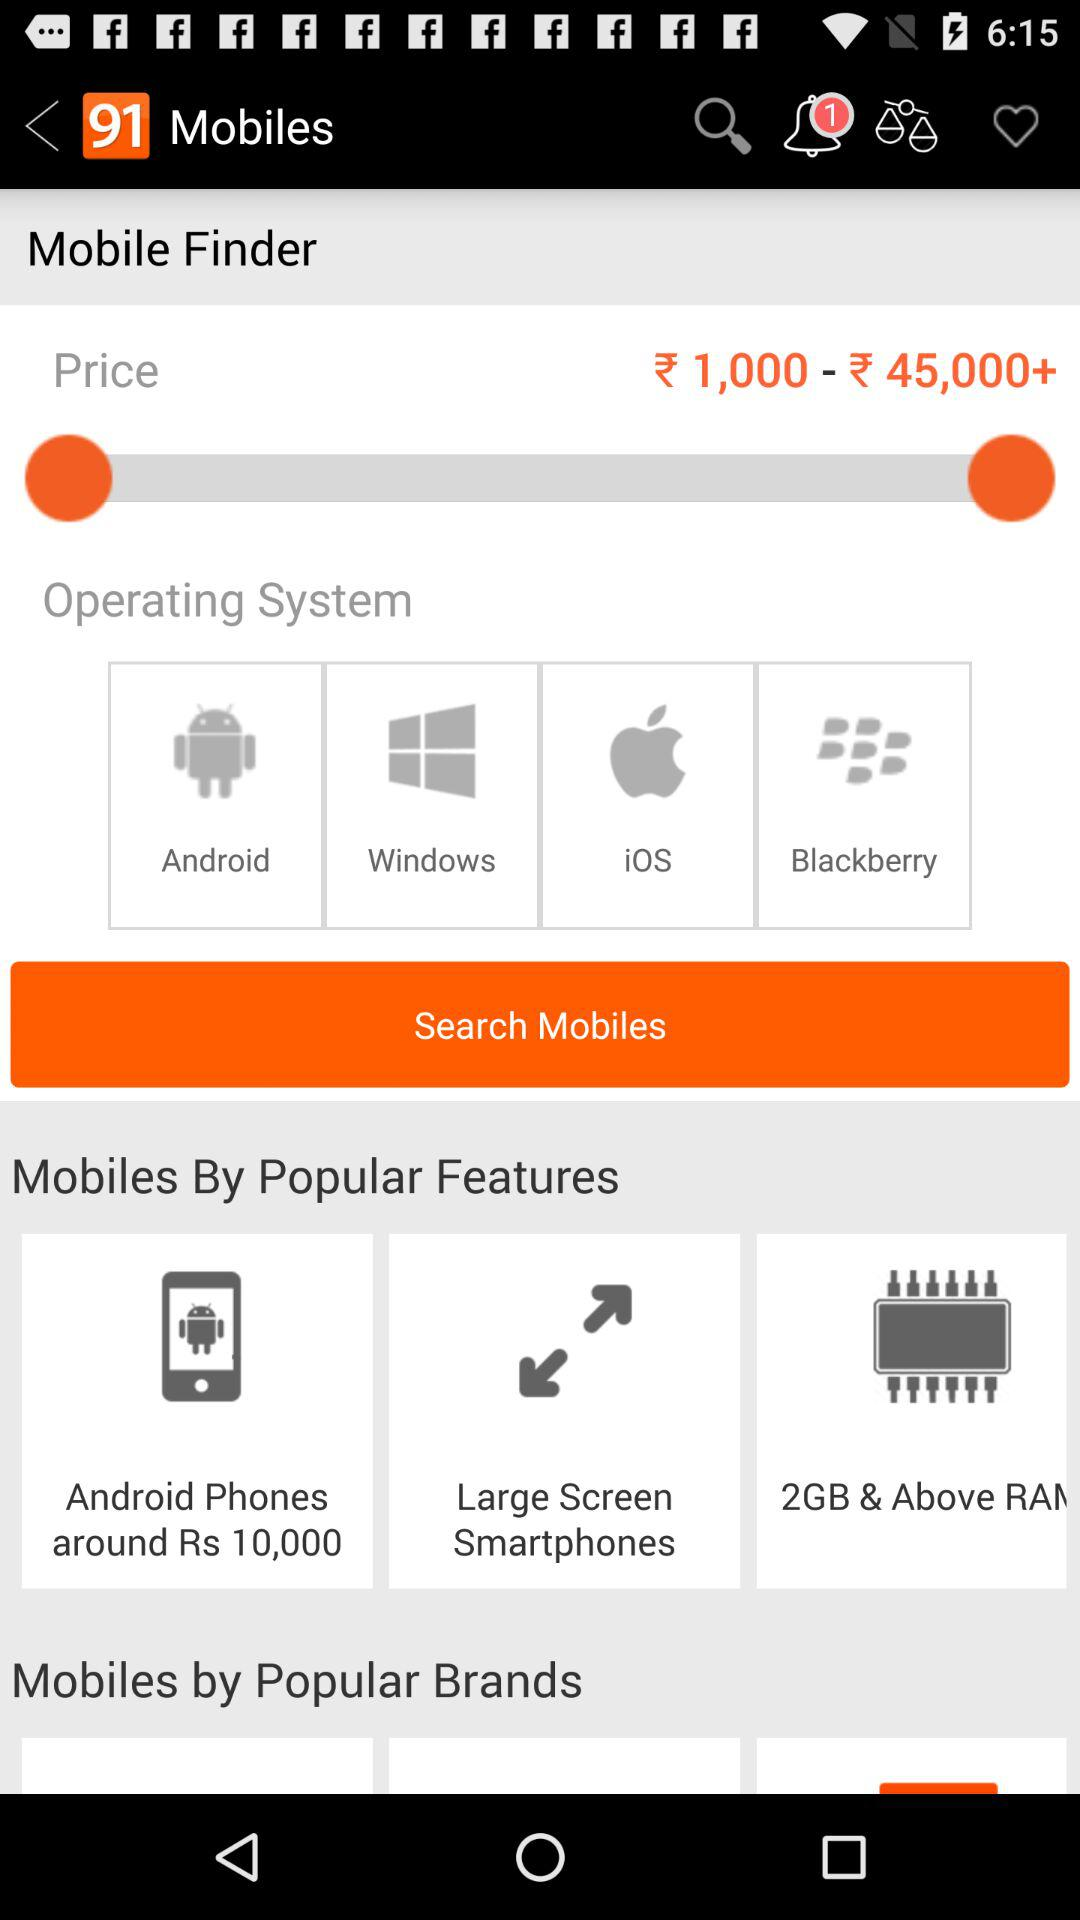How many notifications are there? There is 1 notification. 